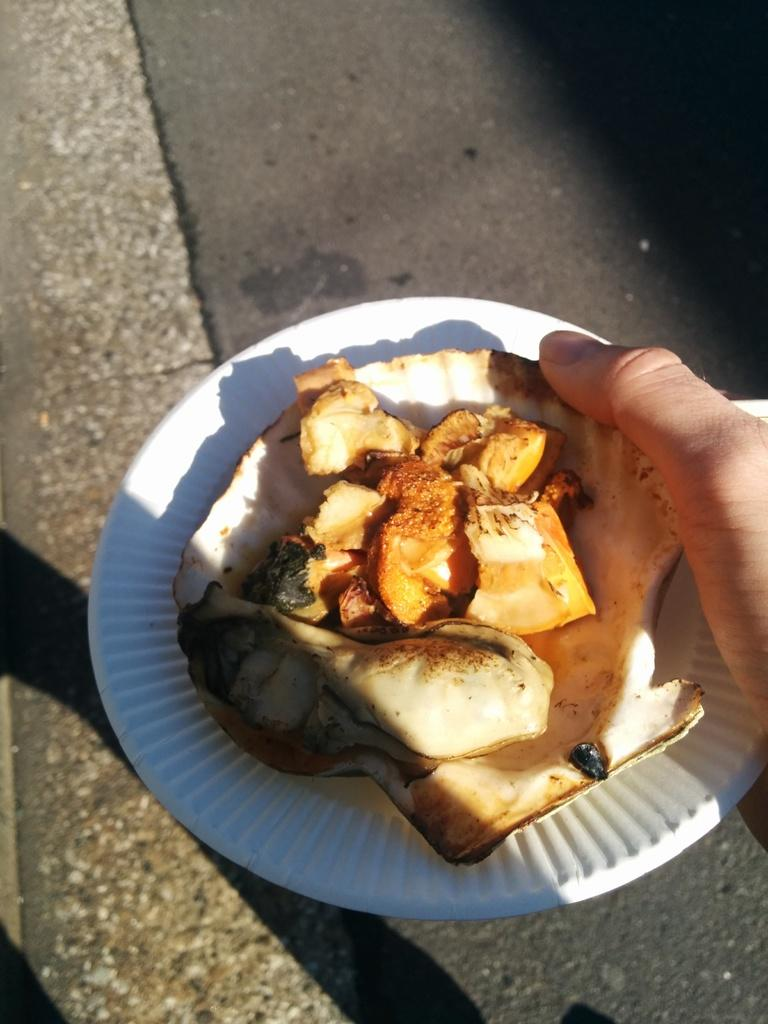What is being held by a person's hand in the image? There is a person's hand holding a plate in the image. What is on the plate that is being held? The plate contains a food item. What can be seen in the background of the image? There is a road visible at the bottom of the image. What type of zinc is present in the image? There is no zinc present in the image. What kind of fowl can be seen walking on the road in the image? There is no fowl visible in the image, and the road is at the bottom of the image, not the top. 